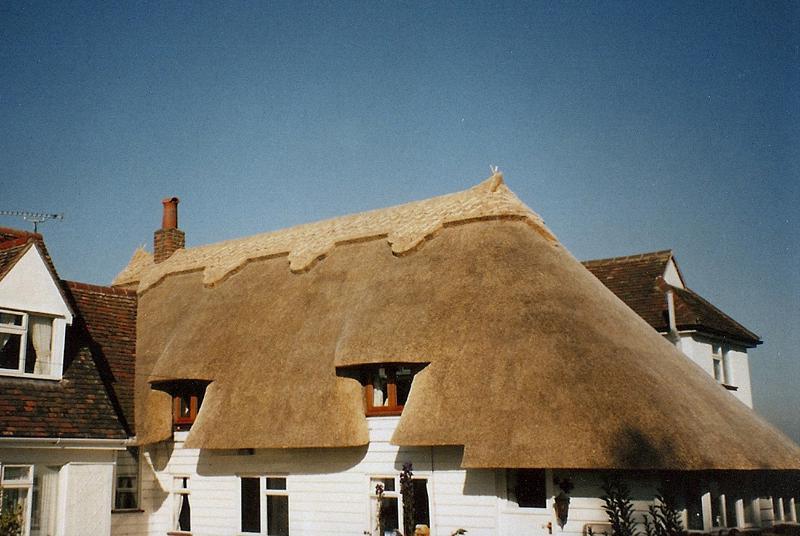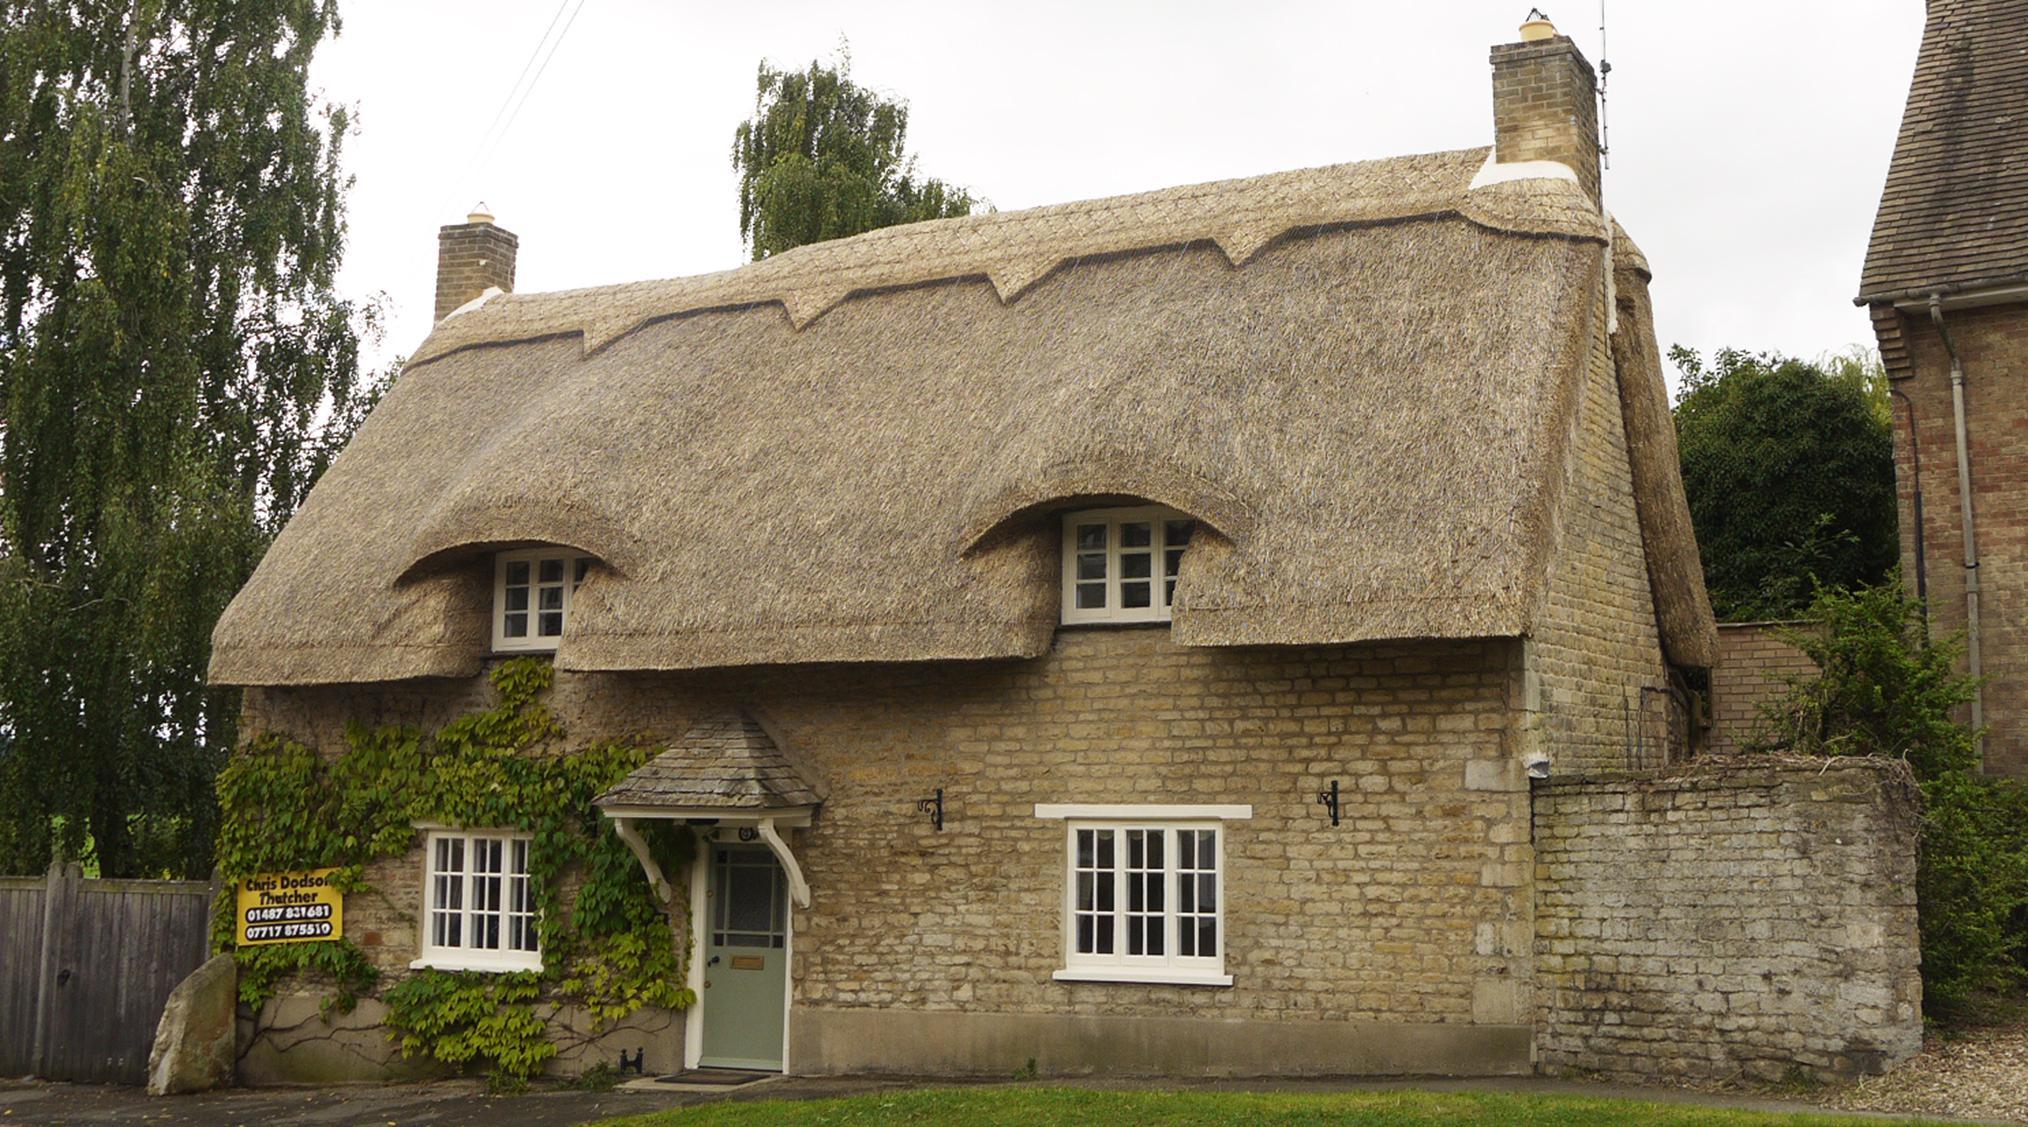The first image is the image on the left, the second image is the image on the right. Assess this claim about the two images: "Each image shows a building with at least one chimney extending up out of a roof with a sculptural decorative cap over its peaked edge.". Correct or not? Answer yes or no. Yes. The first image is the image on the left, the second image is the image on the right. Assess this claim about the two images: "In at least one image there is a house with at least 3 white framed windows and the house and chimney are put together by brick.". Correct or not? Answer yes or no. Yes. 